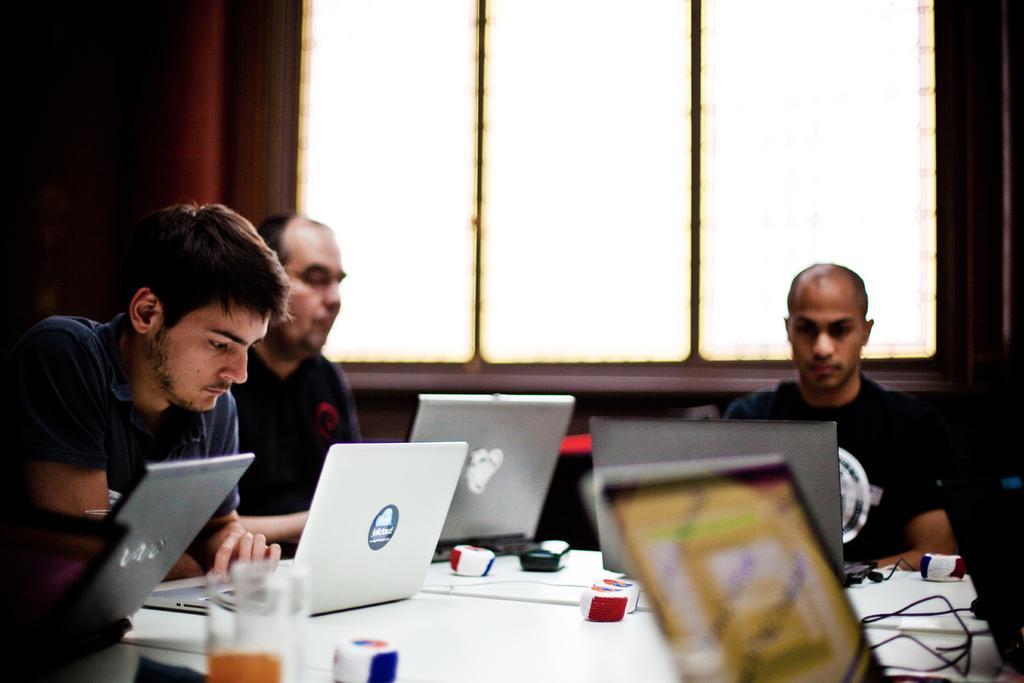Could you give a brief overview of what you see in this image? In this image we can see persons sitting at the table with laptops. On the table laptops, mouses, and glasses. In the background there is a wall and windows. 